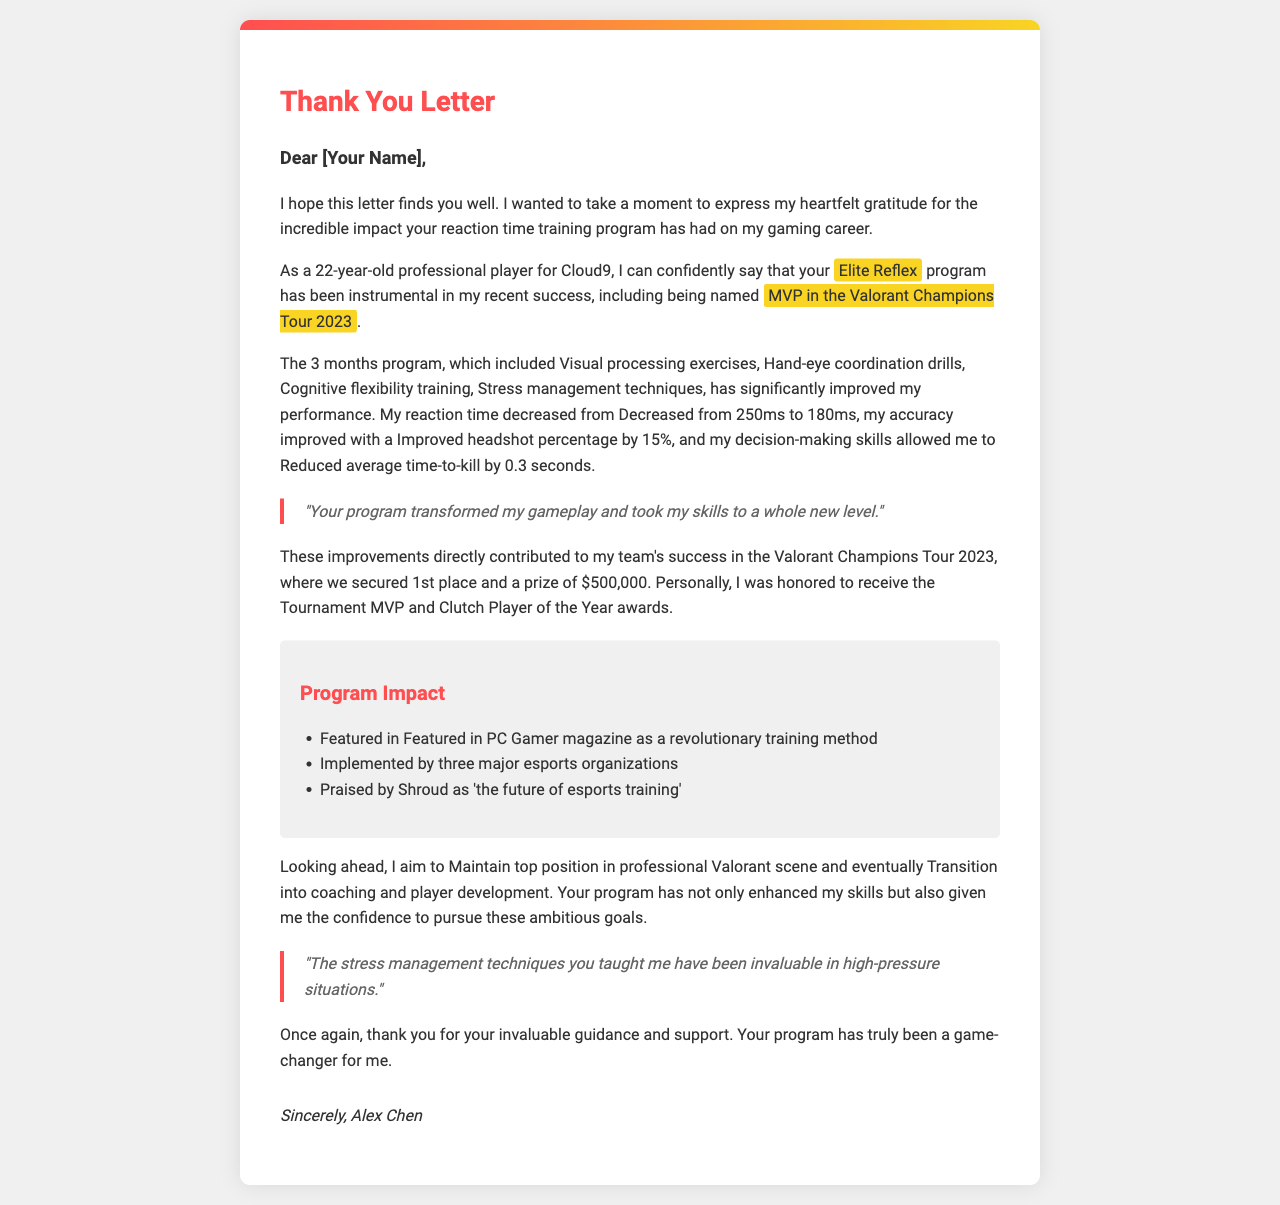What is the name of the student? The student's name is mentioned at the end of the letter under the signature section.
Answer: Alex Chen What program did the student credit for their success? The program credited is highlighted in the letter as the key to the student's achievement.
Answer: Elite Reflex How long did the training program last? The duration of the training program is specified in the letter, reflecting its structured nature.
Answer: 3 months What was the student's achievement in the tournament? The student's specific accolade is stated clearly within the context of their competitive accomplishments.
Answer: MVP in the Valorant Champions Tour 2023 What was the prize money for the tournament? The amount won in the tournament is indicated in the achievements section of the document.
Answer: $500,000 What is one key component of the training program? A specific element of the program is listed among other components, showcasing its comprehensive design.
Answer: Cognitive flexibility training How much did the student's reaction time decrease? The reduction in reaction time is provided as a notable improvement in the student's gaming skills.
Answer: Decreased from 250ms to 180ms What is the student's long-term goal? The student's aspirations for the future are explicitly stated towards the end of the letter.
Answer: Transition into coaching and player development Which magazine featured the program? The recognition of the program is noted in the impact section, demonstrating its industry significance.
Answer: PC Gamer 